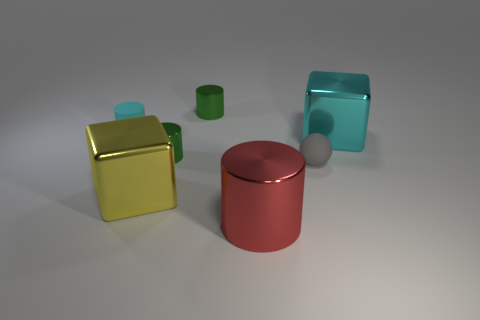What number of large things are made of the same material as the tiny gray thing?
Offer a terse response. 0. There is a shiny cube behind the tiny gray matte object; is its size the same as the cyan thing left of the big cylinder?
Ensure brevity in your answer.  No. The tiny rubber object that is in front of the cyan matte thing is what color?
Ensure brevity in your answer.  Gray. What is the material of the large block that is the same color as the small rubber cylinder?
Offer a very short reply. Metal. How many small metallic things are the same color as the small rubber sphere?
Make the answer very short. 0. Is the size of the red metallic thing the same as the metal cube that is right of the ball?
Provide a short and direct response. Yes. There is a green shiny cylinder that is in front of the green metallic cylinder that is behind the block that is to the right of the matte ball; how big is it?
Your response must be concise. Small. There is a big red object; what number of shiny cubes are on the right side of it?
Make the answer very short. 1. The tiny object that is to the right of the tiny green metal object that is behind the large cyan shiny block is made of what material?
Your answer should be compact. Rubber. Is there anything else that has the same size as the yellow block?
Offer a terse response. Yes. 